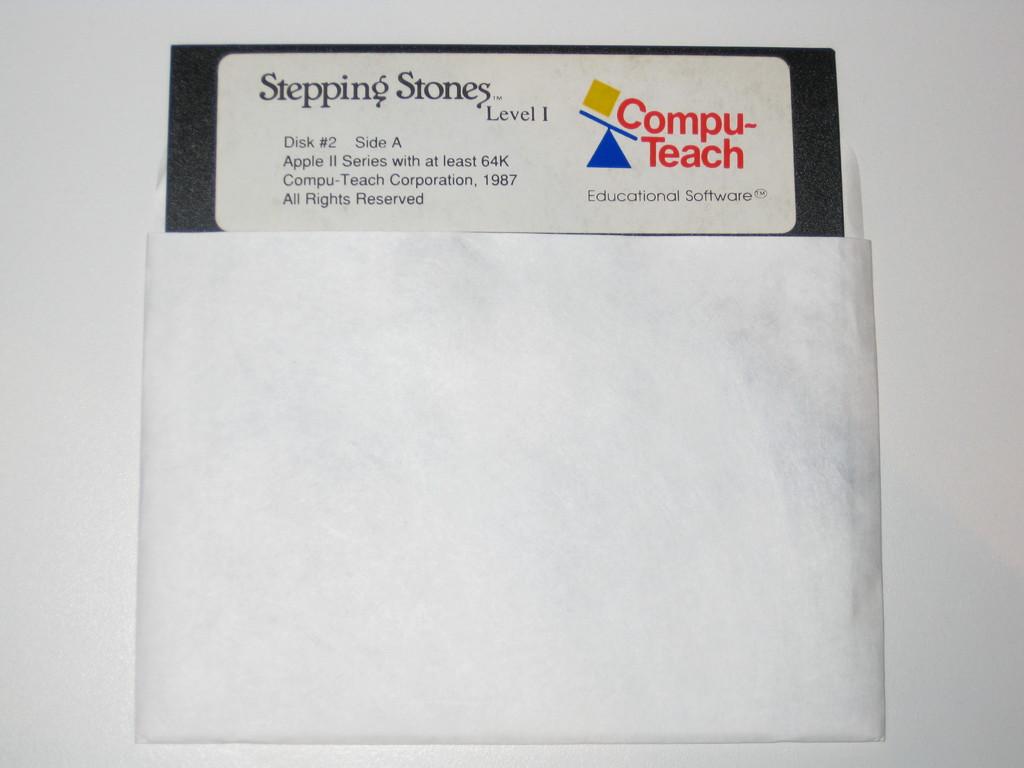What level is this for?
Your answer should be very brief. 1. The date for this floppy disk is?
Keep it short and to the point. 1987. 